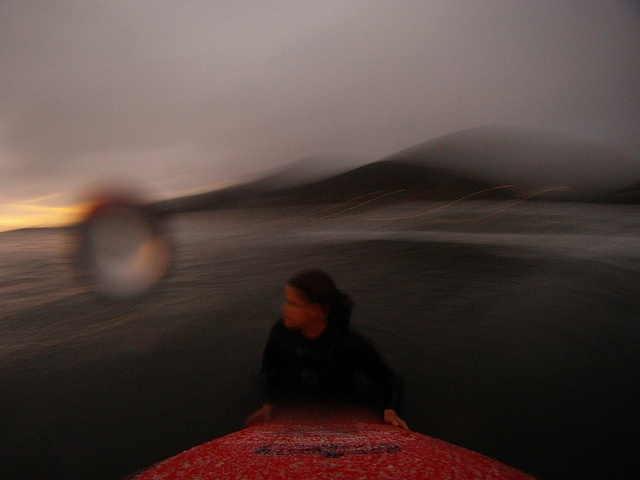Describe the objects in this image and their specific colors. I can see people in black, maroon, and gray tones and surfboard in gray, maroon, black, and brown tones in this image. 